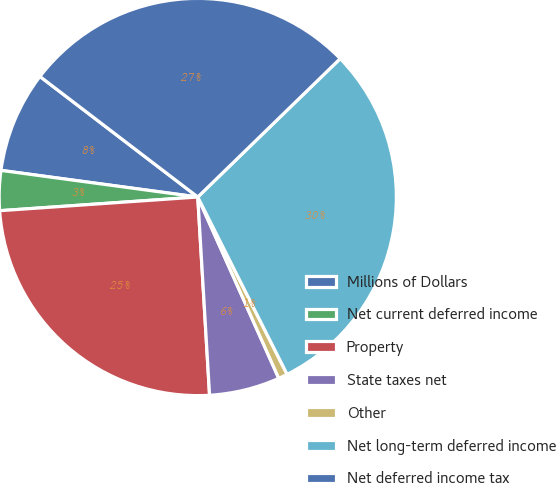<chart> <loc_0><loc_0><loc_500><loc_500><pie_chart><fcel>Millions of Dollars<fcel>Net current deferred income<fcel>Property<fcel>State taxes net<fcel>Other<fcel>Net long-term deferred income<fcel>Net deferred income tax<nl><fcel>8.24%<fcel>3.24%<fcel>24.85%<fcel>5.74%<fcel>0.74%<fcel>29.85%<fcel>27.35%<nl></chart> 